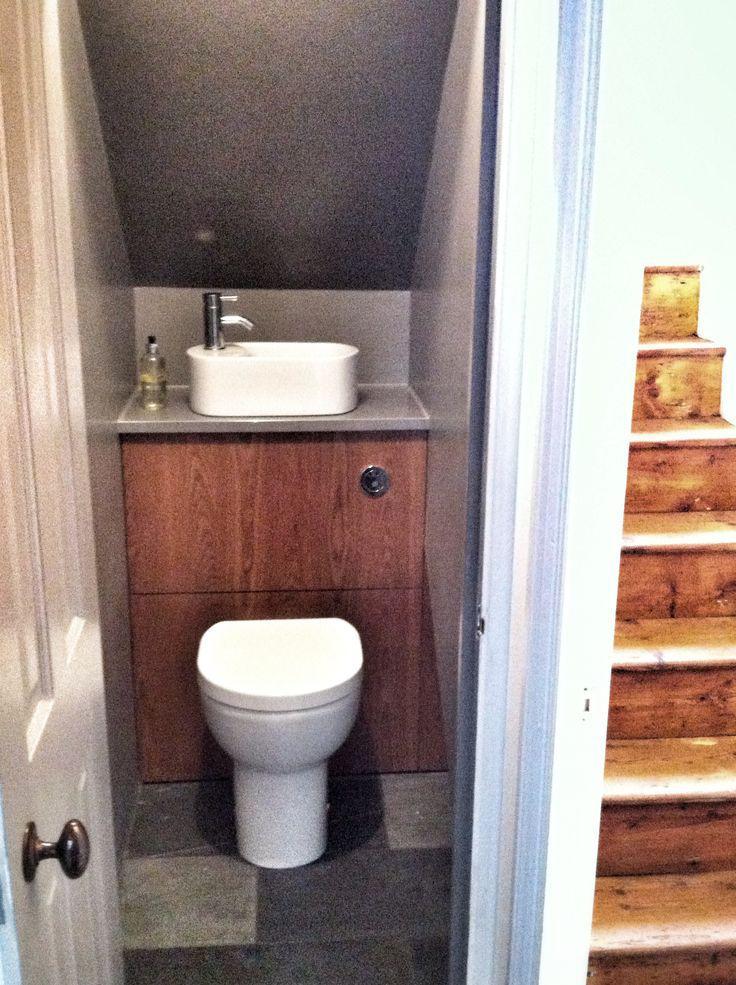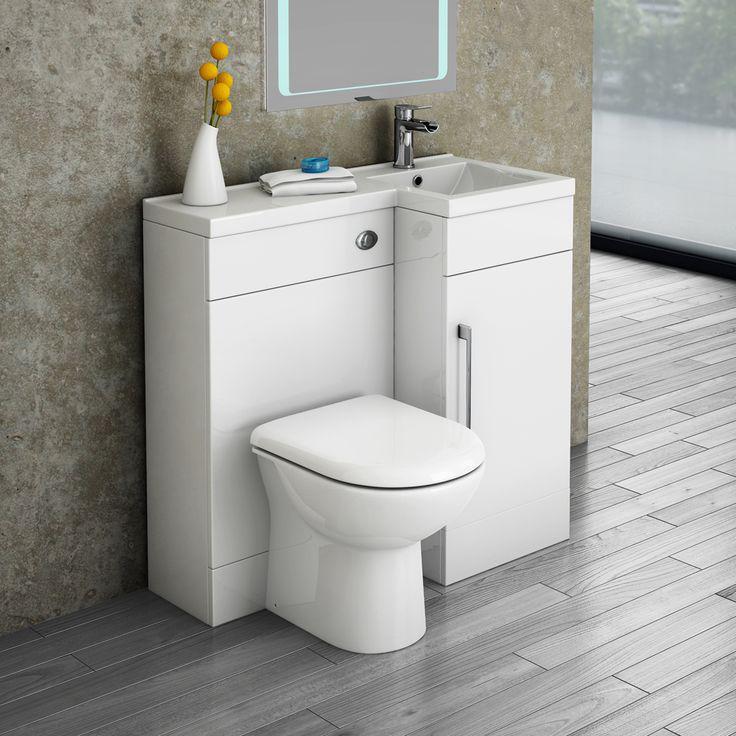The first image is the image on the left, the second image is the image on the right. For the images shown, is this caption "A cabinet sits behind a toilet in the image on the right." true? Answer yes or no. Yes. 